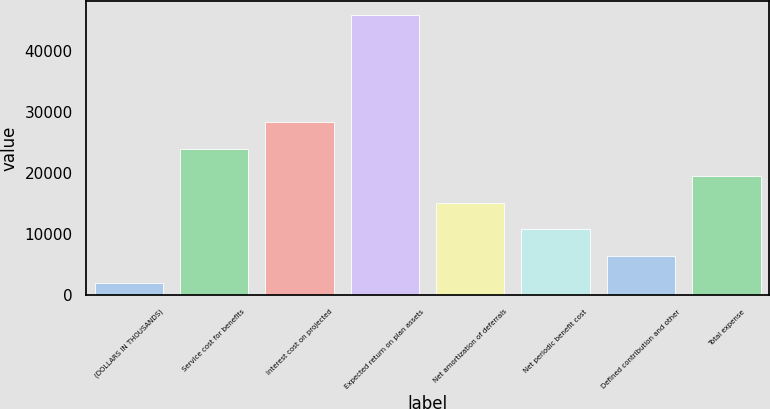Convert chart. <chart><loc_0><loc_0><loc_500><loc_500><bar_chart><fcel>(DOLLARS IN THOUSANDS)<fcel>Service cost for benefits<fcel>Interest cost on projected<fcel>Expected return on plan assets<fcel>Net amortization of deferrals<fcel>Net periodic benefit cost<fcel>Defined contribution and other<fcel>Total expense<nl><fcel>2016<fcel>23940.5<fcel>28325.4<fcel>45865<fcel>15170.7<fcel>10785.8<fcel>6400.9<fcel>19555.6<nl></chart> 